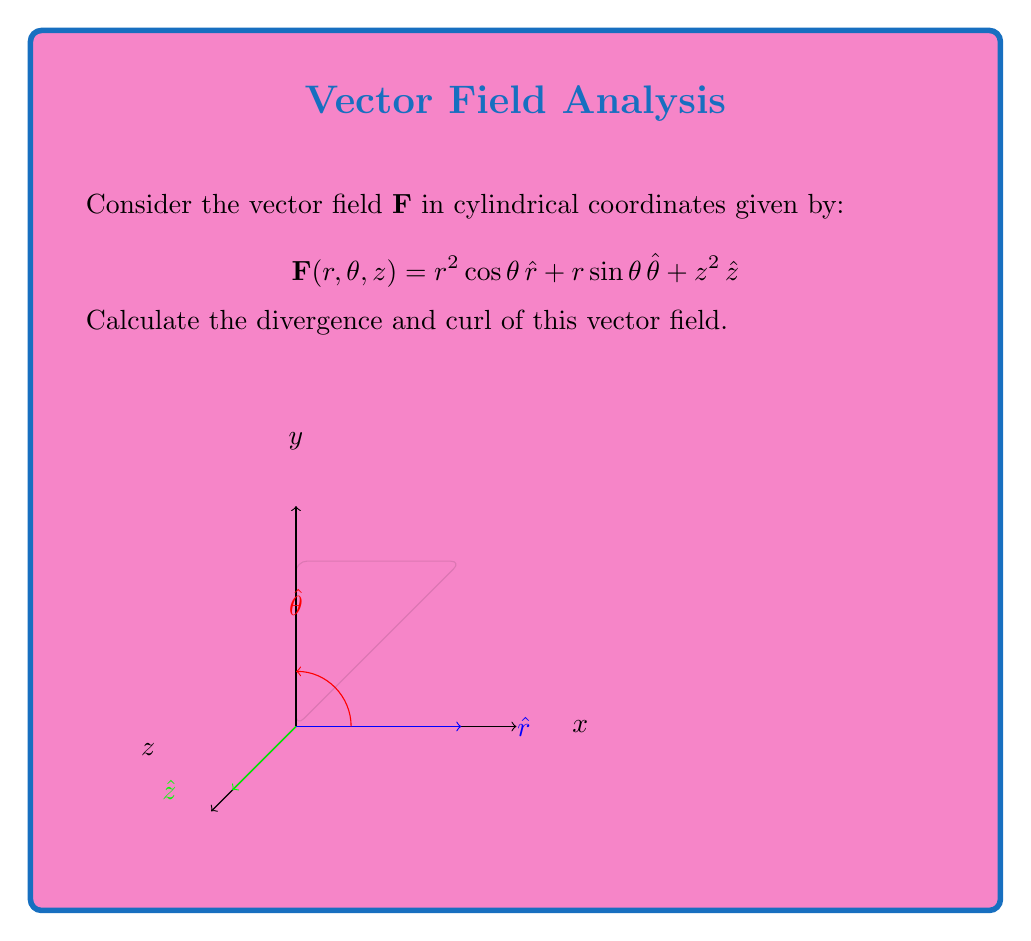Show me your answer to this math problem. To analyze the divergence and curl of the vector field in cylindrical coordinates, we'll use the following formulas:

1. Divergence in cylindrical coordinates:
   $$\text{div}\,\mathbf{F} = \nabla \cdot \mathbf{F} = \frac{1}{r}\frac{\partial}{\partial r}(rF_r) + \frac{1}{r}\frac{\partial F_\theta}{\partial \theta} + \frac{\partial F_z}{\partial z}$$

2. Curl in cylindrical coordinates:
   $$\text{curl}\,\mathbf{F} = \nabla \times \mathbf{F} = \left(\frac{1}{r}\frac{\partial F_z}{\partial \theta} - \frac{\partial F_\theta}{\partial z}\right)\hat{r} + \left(\frac{\partial F_r}{\partial z} - \frac{\partial F_z}{\partial r}\right)\hat{\theta} + \frac{1}{r}\left(\frac{\partial}{\partial r}(rF_\theta) - \frac{\partial F_r}{\partial \theta}\right)\hat{z}$$

Let's calculate each component:

Divergence:
1. $\frac{1}{r}\frac{\partial}{\partial r}(rF_r) = \frac{1}{r}\frac{\partial}{\partial r}(r^3\cos\theta) = \frac{1}{r}(3r^2\cos\theta) = 3r\cos\theta$
2. $\frac{1}{r}\frac{\partial F_\theta}{\partial \theta} = \frac{1}{r}\frac{\partial}{\partial \theta}(r\sin\theta) = \frac{1}{r}(r\cos\theta) = \cos\theta$
3. $\frac{\partial F_z}{\partial z} = \frac{\partial}{\partial z}(z^2) = 2z$

Adding these components: $\text{div}\,\mathbf{F} = 3r\cos\theta + \cos\theta + 2z$

Curl:
1. $\frac{1}{r}\frac{\partial F_z}{\partial \theta} - \frac{\partial F_\theta}{\partial z} = \frac{1}{r}\frac{\partial}{\partial \theta}(z^2) - \frac{\partial}{\partial z}(r\sin\theta) = 0 - 0 = 0$
2. $\frac{\partial F_r}{\partial z} - \frac{\partial F_z}{\partial r} = \frac{\partial}{\partial z}(r^2\cos\theta) - \frac{\partial}{\partial r}(z^2) = 0 - 0 = 0$
3. $\frac{1}{r}\left(\frac{\partial}{\partial r}(rF_\theta) - \frac{\partial F_r}{\partial \theta}\right) = \frac{1}{r}\left(\frac{\partial}{\partial r}(r^2\sin\theta) - \frac{\partial}{\partial \theta}(r^2\cos\theta)\right) = \frac{1}{r}(2r\sin\theta + r^2\sin\theta) = 2\sin\theta + r\sin\theta$

Therefore, $\text{curl}\,\mathbf{F} = (2\sin\theta + r\sin\theta)\hat{z}$
Answer: $\text{div}\,\mathbf{F} = 3r\cos\theta + \cos\theta + 2z$
$\text{curl}\,\mathbf{F} = (2\sin\theta + r\sin\theta)\hat{z}$ 